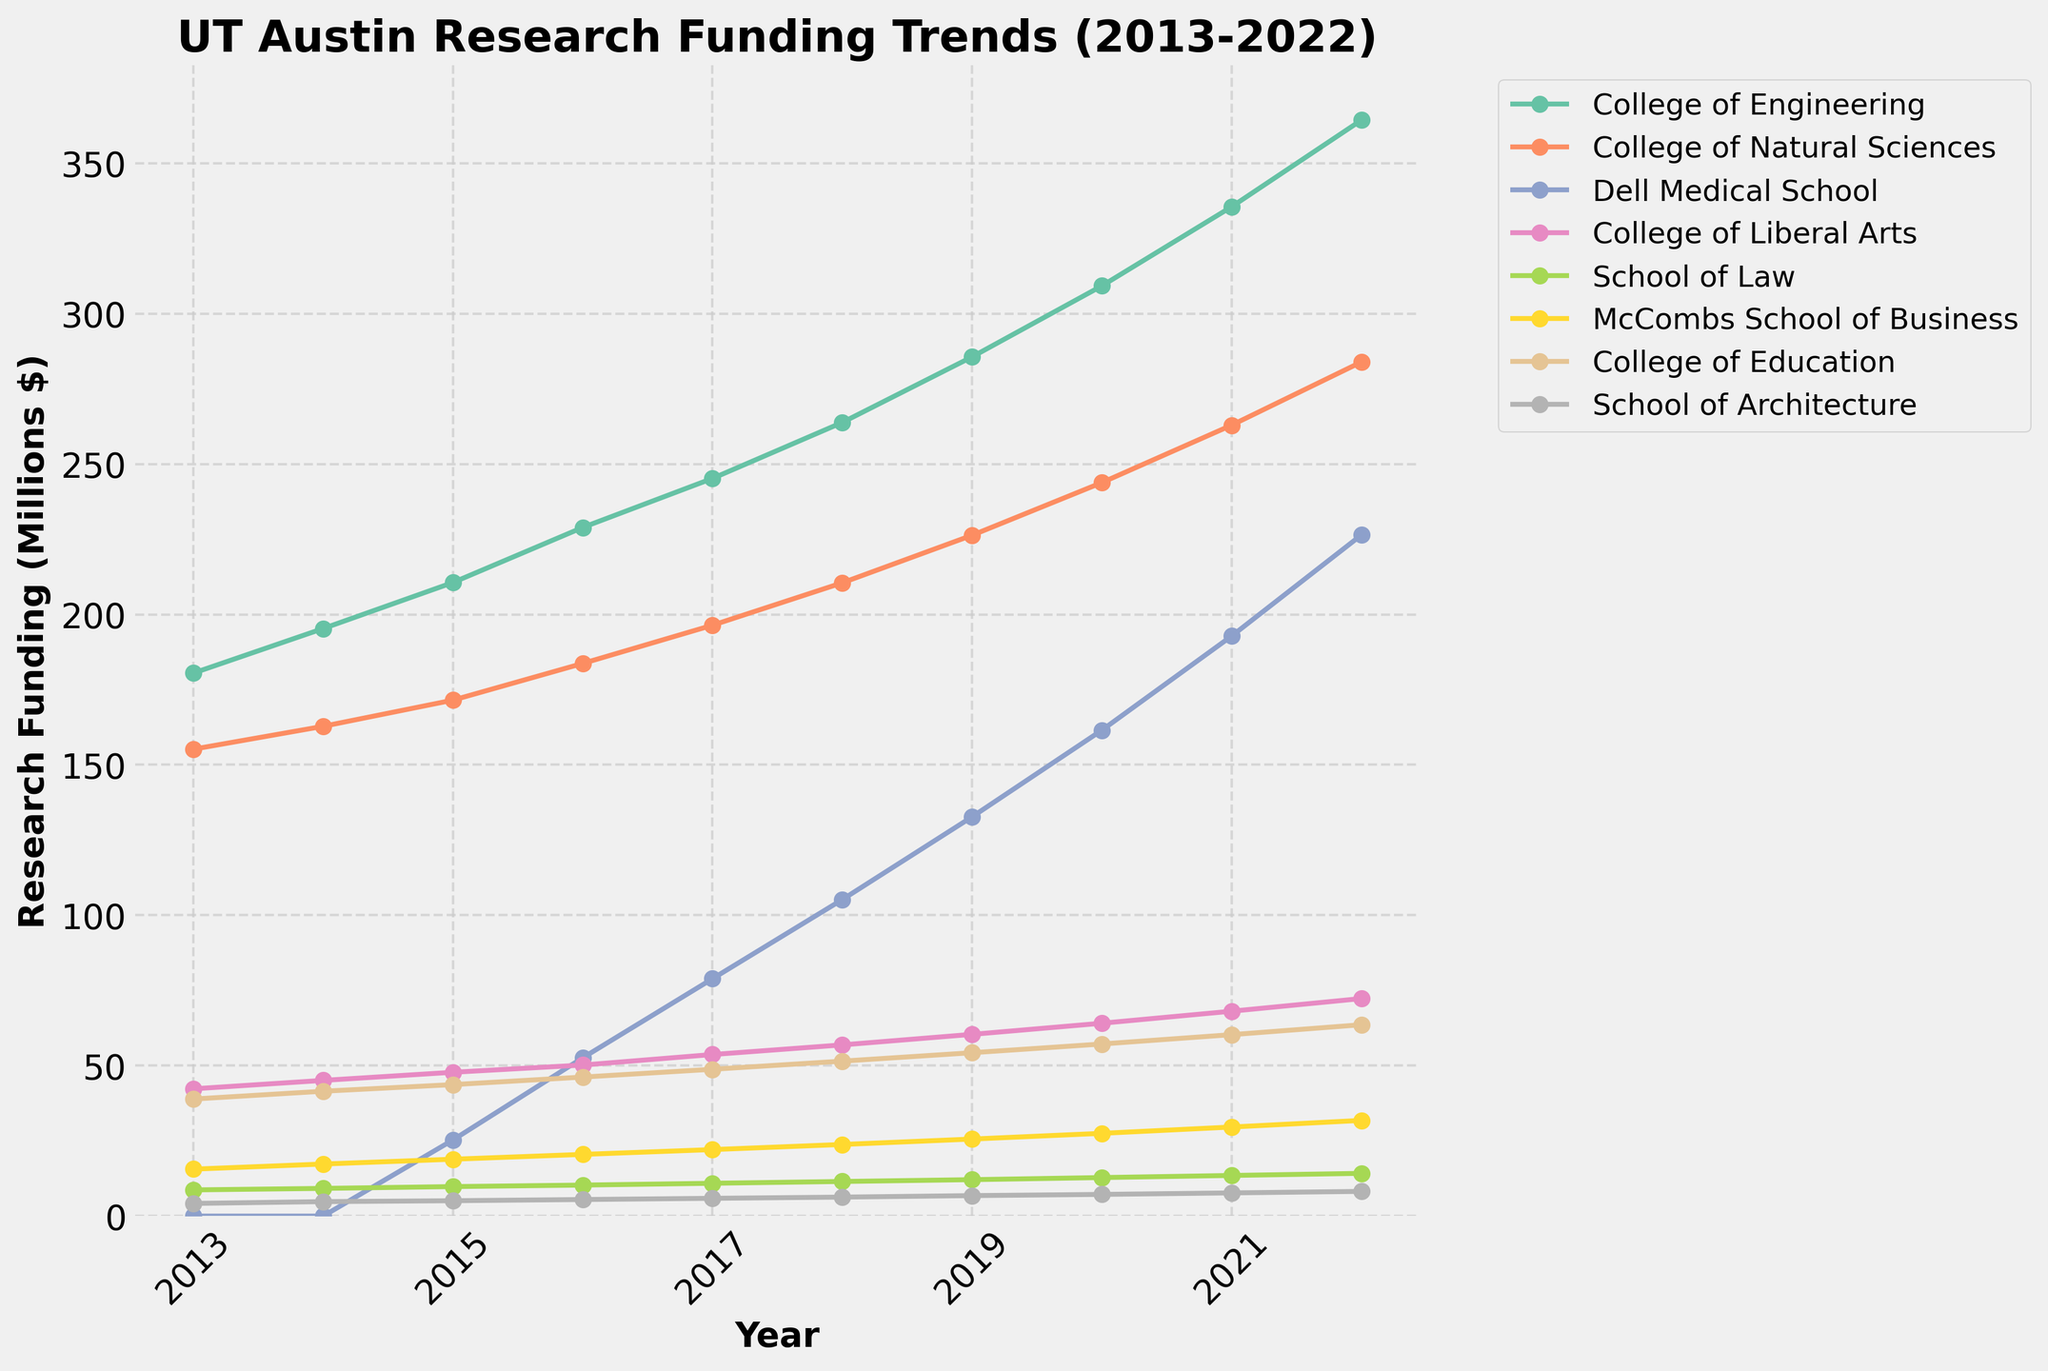How has the research funding for the College of Engineering changed from 2013 to 2022? Find the value for the College of Engineering in 2022 and subtract the value from 2013. The funding in 2022 is 364.3 million dollars, and in 2013 it was 180.5 million dollars. So, the change is 364.3 - 180.5 = 183.8 million dollars.
Answer: 183.8 million dollars Which department had the highest increase in research funding between 2013 and 2022? Subtract the 2013 funding from the 2022 funding for each department and compare the results. The Dell Medical School shows the highest increase from 0 in 2013 to 226.4 million dollars in 2022.
Answer: Dell Medical School What's the difference in research funding between the College of Education and the College of Liberal Arts in 2021? Look for the funding amounts for both colleges in 2021 and subtract the smaller amount from the larger. For the College of Education, it is 60.3 million dollars, and for the College of Liberal Arts, it is 68.1 million dollars. The difference is 68.1 - 60.3 = 7.8 million dollars.
Answer: 7.8 million dollars Which department has shown the most consistent increase in research funding over the years? Observe the trends in the lines for each department. The College of Engineering shows a consistent and steady increase every year.
Answer: College of Engineering What was the average research funding for the School of Architecture over the 10-year period? Add the funding amounts for the School of Architecture from each year and divide by the number of years (10). The funds are 4.2, 4.8, 5.1, 5.5, 5.9, 6.3, 6.8, 7.2, 7.7, and 8.2 respectively. The sum is 61.7, and the average is 61.7/10 = 6.17 million dollars.
Answer: 6.17 million dollars In which year did McCombs School of Business surpass 20 million dollars in funding? Look along the line for McCombs School of Business to find the point where it crosses the 20 million dollar mark. It crosses in 2016.
Answer: 2016 What's the total research funding for all departments in 2018? Sum up all departmental funding amounts for the year 2018. The amounts are 263.8, 210.5, 105.2, 56.9, 11.5, 23.8, 51.5, and 6.3 respectively. The total is 263.8 + 210.5 + 105.2 + 56.9 + 11.5 + 23.8 + 51.5 + 6.3 = 729.5 million dollars.
Answer: 729.5 million dollars Which two departments had the smallest difference in research funding in 2020? Calculate the absolute difference in the research funding between every pair of departments in 2020, then find the smallest one. School of Law (12.8 million dollars) and School of Architecture (7.2 million dollars) have the smallest difference of
Answer: 5.6 million dollars Which year saw the most significant increase in research funding for the Dell Medical School compared to the previous year? Calculate the year-on-year increase for the Dell Medical School and find the maximum value. The increases are: 2015-2014 = 25.3 million dollars, 2016-2015 = 27.3 million dollars, 2017-2016 = 26.3 million dollars, 2018-2017 = 26.3 million dollars, 2019-2018 = 27.5 million dollars, 2020-2019 = 28.8 million dollars, 2021-2020 = 31.3 million dollars, 2022-2021 = 33.6 million dollars. The most significant increase happened in 2022.
Answer: 2022 